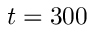Convert formula to latex. <formula><loc_0><loc_0><loc_500><loc_500>t = 3 0 0</formula> 